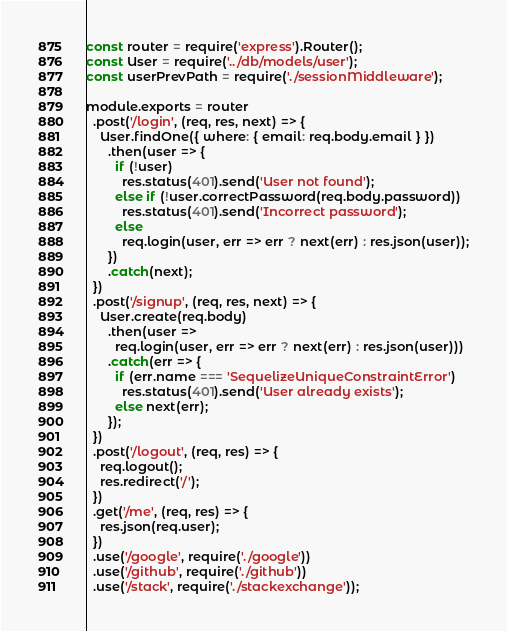Convert code to text. <code><loc_0><loc_0><loc_500><loc_500><_JavaScript_>const router = require('express').Router();
const User = require('../db/models/user');
const userPrevPath = require('./sessionMiddleware');

module.exports = router
  .post('/login', (req, res, next) => {
    User.findOne({ where: { email: req.body.email } })
      .then(user => {
        if (!user)
          res.status(401).send('User not found');
        else if (!user.correctPassword(req.body.password))
          res.status(401).send('Incorrect password');
        else
          req.login(user, err => err ? next(err) : res.json(user));
      })
      .catch(next);
  })
  .post('/signup', (req, res, next) => {
    User.create(req.body)
      .then(user =>
        req.login(user, err => err ? next(err) : res.json(user)))
      .catch(err => {
        if (err.name === 'SequelizeUniqueConstraintError')
          res.status(401).send('User already exists');
        else next(err);
      });
  })
  .post('/logout', (req, res) => {
    req.logout();
    res.redirect('/');
  })
  .get('/me', (req, res) => {
    res.json(req.user);
  })
  .use('/google', require('./google'))
  .use('/github', require('./github'))
  .use('/stack', require('./stackexchange'));
</code> 